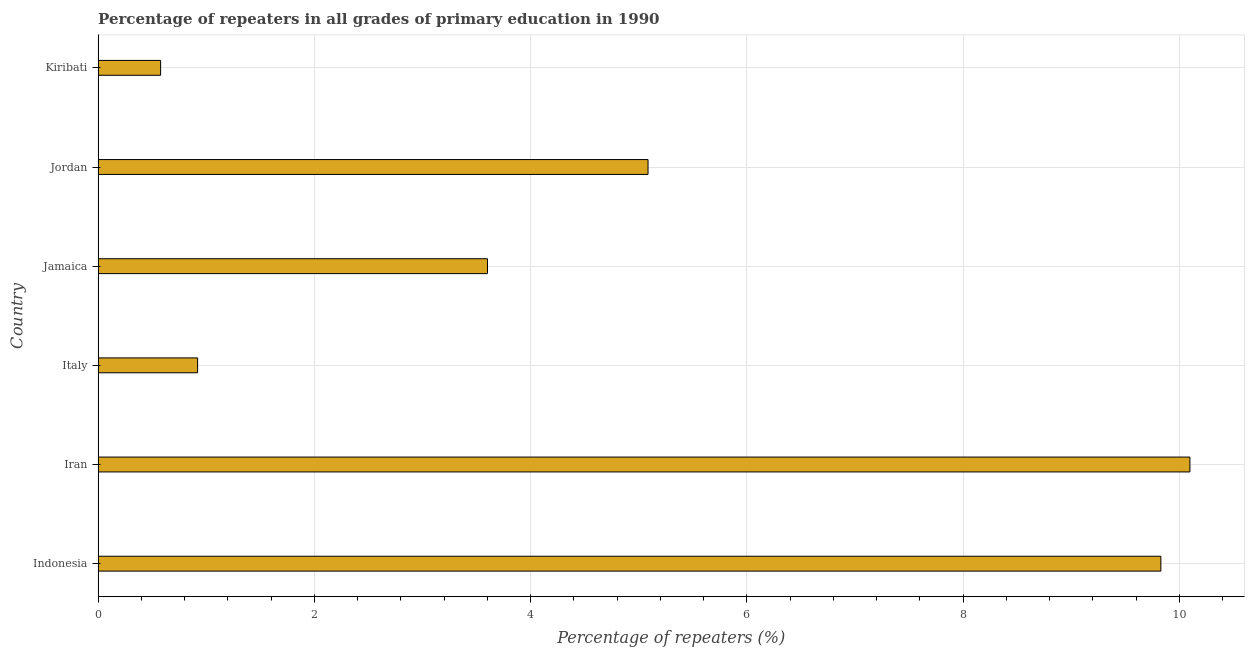Does the graph contain any zero values?
Provide a short and direct response. No. Does the graph contain grids?
Ensure brevity in your answer.  Yes. What is the title of the graph?
Offer a very short reply. Percentage of repeaters in all grades of primary education in 1990. What is the label or title of the X-axis?
Make the answer very short. Percentage of repeaters (%). What is the label or title of the Y-axis?
Your answer should be very brief. Country. What is the percentage of repeaters in primary education in Jamaica?
Your response must be concise. 3.6. Across all countries, what is the maximum percentage of repeaters in primary education?
Make the answer very short. 10.1. Across all countries, what is the minimum percentage of repeaters in primary education?
Keep it short and to the point. 0.58. In which country was the percentage of repeaters in primary education maximum?
Keep it short and to the point. Iran. In which country was the percentage of repeaters in primary education minimum?
Provide a short and direct response. Kiribati. What is the sum of the percentage of repeaters in primary education?
Your answer should be compact. 30.11. What is the difference between the percentage of repeaters in primary education in Iran and Kiribati?
Your response must be concise. 9.52. What is the average percentage of repeaters in primary education per country?
Your response must be concise. 5.02. What is the median percentage of repeaters in primary education?
Your answer should be very brief. 4.34. In how many countries, is the percentage of repeaters in primary education greater than 9.2 %?
Keep it short and to the point. 2. What is the ratio of the percentage of repeaters in primary education in Indonesia to that in Italy?
Make the answer very short. 10.68. Is the percentage of repeaters in primary education in Indonesia less than that in Iran?
Provide a short and direct response. Yes. What is the difference between the highest and the second highest percentage of repeaters in primary education?
Provide a short and direct response. 0.27. What is the difference between the highest and the lowest percentage of repeaters in primary education?
Your answer should be very brief. 9.52. How many bars are there?
Provide a short and direct response. 6. How many countries are there in the graph?
Your response must be concise. 6. What is the difference between two consecutive major ticks on the X-axis?
Ensure brevity in your answer.  2. What is the Percentage of repeaters (%) of Indonesia?
Offer a very short reply. 9.83. What is the Percentage of repeaters (%) in Iran?
Offer a very short reply. 10.1. What is the Percentage of repeaters (%) of Italy?
Keep it short and to the point. 0.92. What is the Percentage of repeaters (%) in Jamaica?
Make the answer very short. 3.6. What is the Percentage of repeaters (%) of Jordan?
Your response must be concise. 5.09. What is the Percentage of repeaters (%) in Kiribati?
Ensure brevity in your answer.  0.58. What is the difference between the Percentage of repeaters (%) in Indonesia and Iran?
Ensure brevity in your answer.  -0.27. What is the difference between the Percentage of repeaters (%) in Indonesia and Italy?
Provide a short and direct response. 8.91. What is the difference between the Percentage of repeaters (%) in Indonesia and Jamaica?
Your response must be concise. 6.23. What is the difference between the Percentage of repeaters (%) in Indonesia and Jordan?
Provide a short and direct response. 4.74. What is the difference between the Percentage of repeaters (%) in Indonesia and Kiribati?
Provide a succinct answer. 9.25. What is the difference between the Percentage of repeaters (%) in Iran and Italy?
Make the answer very short. 9.18. What is the difference between the Percentage of repeaters (%) in Iran and Jamaica?
Keep it short and to the point. 6.5. What is the difference between the Percentage of repeaters (%) in Iran and Jordan?
Your answer should be very brief. 5.01. What is the difference between the Percentage of repeaters (%) in Iran and Kiribati?
Keep it short and to the point. 9.52. What is the difference between the Percentage of repeaters (%) in Italy and Jamaica?
Keep it short and to the point. -2.68. What is the difference between the Percentage of repeaters (%) in Italy and Jordan?
Keep it short and to the point. -4.17. What is the difference between the Percentage of repeaters (%) in Italy and Kiribati?
Offer a very short reply. 0.34. What is the difference between the Percentage of repeaters (%) in Jamaica and Jordan?
Keep it short and to the point. -1.48. What is the difference between the Percentage of repeaters (%) in Jamaica and Kiribati?
Your answer should be compact. 3.02. What is the difference between the Percentage of repeaters (%) in Jordan and Kiribati?
Provide a succinct answer. 4.51. What is the ratio of the Percentage of repeaters (%) in Indonesia to that in Iran?
Ensure brevity in your answer.  0.97. What is the ratio of the Percentage of repeaters (%) in Indonesia to that in Italy?
Offer a very short reply. 10.68. What is the ratio of the Percentage of repeaters (%) in Indonesia to that in Jamaica?
Provide a succinct answer. 2.73. What is the ratio of the Percentage of repeaters (%) in Indonesia to that in Jordan?
Keep it short and to the point. 1.93. What is the ratio of the Percentage of repeaters (%) in Indonesia to that in Kiribati?
Give a very brief answer. 17.01. What is the ratio of the Percentage of repeaters (%) in Iran to that in Italy?
Your answer should be compact. 10.97. What is the ratio of the Percentage of repeaters (%) in Iran to that in Jamaica?
Your answer should be compact. 2.8. What is the ratio of the Percentage of repeaters (%) in Iran to that in Jordan?
Make the answer very short. 1.99. What is the ratio of the Percentage of repeaters (%) in Iran to that in Kiribati?
Your answer should be compact. 17.47. What is the ratio of the Percentage of repeaters (%) in Italy to that in Jamaica?
Provide a succinct answer. 0.26. What is the ratio of the Percentage of repeaters (%) in Italy to that in Jordan?
Your answer should be compact. 0.18. What is the ratio of the Percentage of repeaters (%) in Italy to that in Kiribati?
Your answer should be compact. 1.59. What is the ratio of the Percentage of repeaters (%) in Jamaica to that in Jordan?
Offer a very short reply. 0.71. What is the ratio of the Percentage of repeaters (%) in Jamaica to that in Kiribati?
Provide a succinct answer. 6.23. 